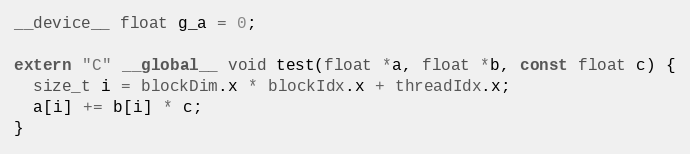<code> <loc_0><loc_0><loc_500><loc_500><_Cuda_>__device__ float g_a = 0;

extern "C" __global__ void test(float *a, float *b, const float c) {
  size_t i = blockDim.x * blockIdx.x + threadIdx.x;
  a[i] += b[i] * c;
}
</code> 